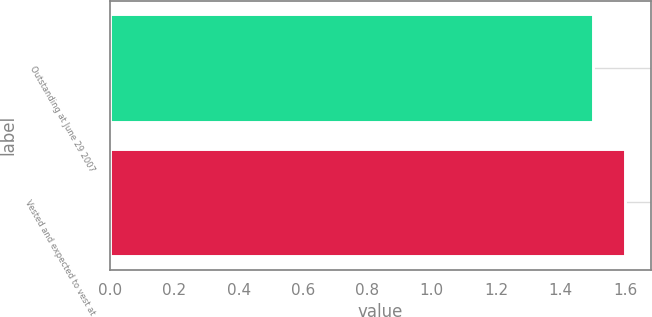<chart> <loc_0><loc_0><loc_500><loc_500><bar_chart><fcel>Outstanding at June 29 2007<fcel>Vested and expected to vest at<nl><fcel>1.5<fcel>1.6<nl></chart> 